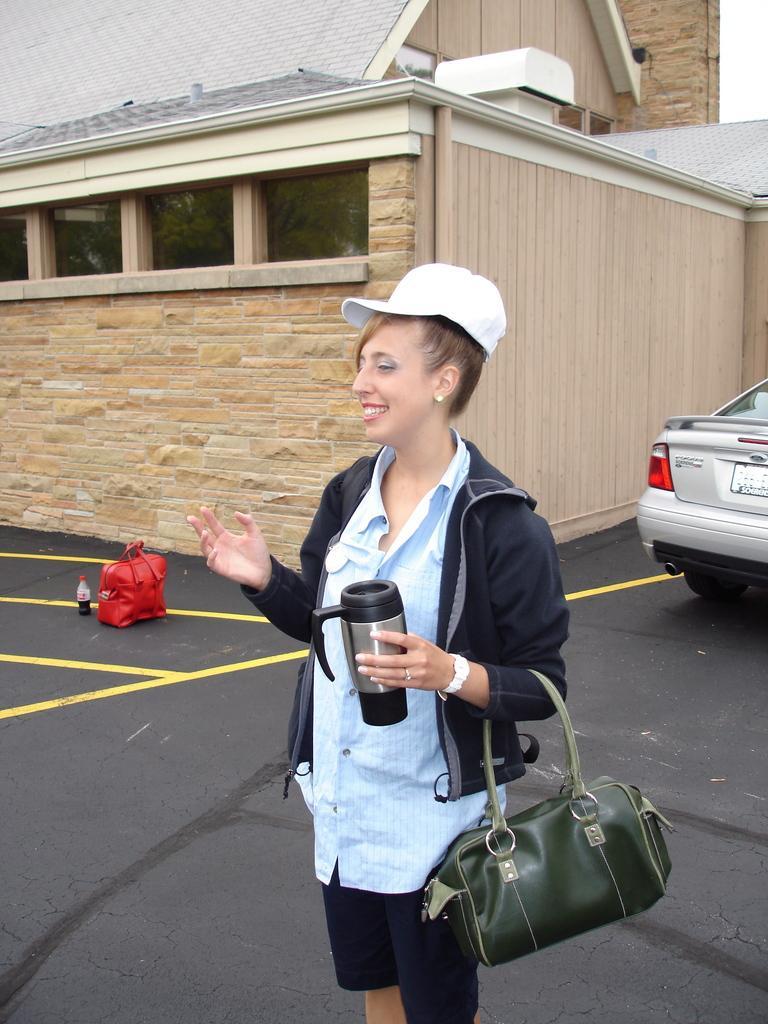How would you summarize this image in a sentence or two? In the middle of the image a woman is standing and smiling and she is holding a cup. In the middle of the image there is a red color bag, Beside the bag there is a bottle. At the top of the image there is a building. Bottom right side of the image there is a car. 